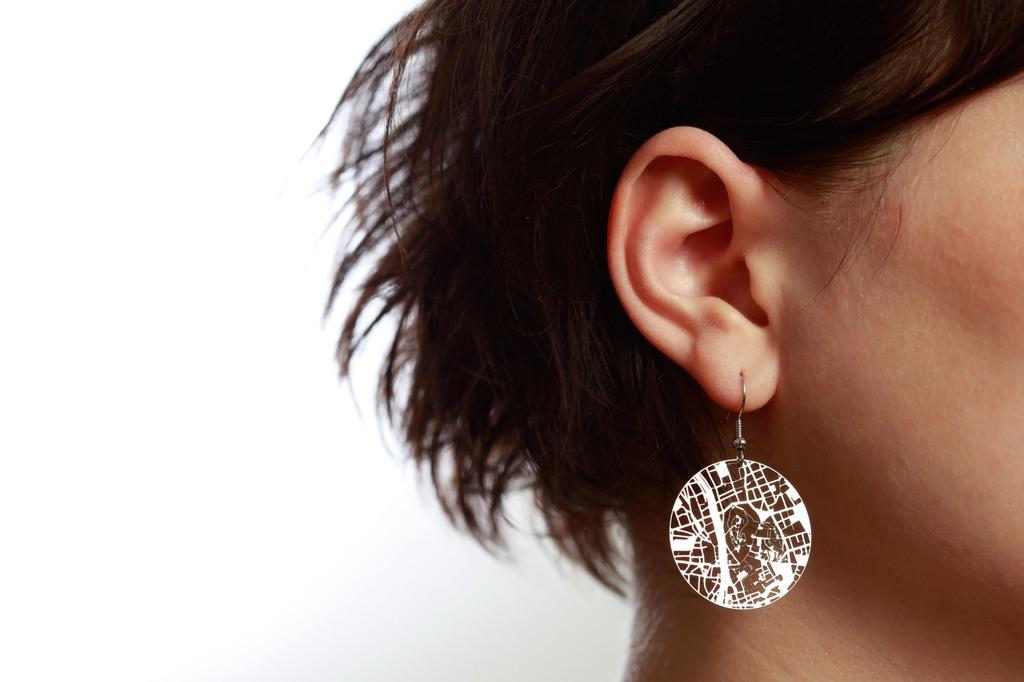What is located on the right side of the image? There is a person's head on the right side of the image. What accessory can be seen on the person's ear? The person has an earring in their ear. What color is the background of the image? The background of the image is white. What advice does the kitten give to the person in the image? There is no kitten present in the image, so it cannot provide any advice. 